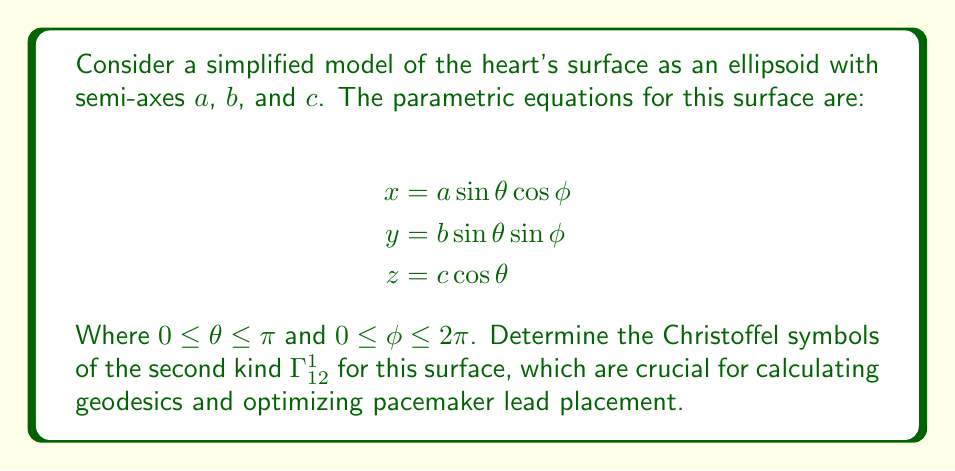Show me your answer to this math problem. To find the Christoffel symbol $\Gamma_{12}^1$, we need to follow these steps:

1) First, calculate the metric tensor components. The metric tensor is given by:

   $$g_{ij} = \frac{\partial \mathbf{r}}{\partial u_i} \cdot \frac{\partial \mathbf{r}}{\partial u_j}$$

   Where $\mathbf{r} = (x, y, z)$ and $(u_1, u_2) = (\theta, \phi)$.

2) Calculate the partial derivatives:

   $$\frac{\partial \mathbf{r}}{\partial \theta} = (a\cos\theta\cos\phi, b\cos\theta\sin\phi, -c\sin\theta)$$
   $$\frac{\partial \mathbf{r}}{\partial \phi} = (-a\sin\theta\sin\phi, b\sin\theta\cos\phi, 0)$$

3) Now, compute the metric tensor components:

   $$g_{11} = a^2\cos^2\theta\cos^2\phi + b^2\cos^2\theta\sin^2\phi + c^2\sin^2\theta$$
   $$g_{12} = g_{21} = -a^2\sin\theta\cos\theta\sin\phi\cos\phi + b^2\sin\theta\cos\theta\sin\phi\cos\phi = (b^2-a^2)\sin\theta\cos\theta\sin\phi\cos\phi$$
   $$g_{22} = a^2\sin^2\theta\sin^2\phi + b^2\sin^2\theta\cos^2\phi$$

4) The Christoffel symbol of the second kind is given by:

   $$\Gamma_{ij}^k = \frac{1}{2}g^{kl}\left(\frac{\partial g_{il}}{\partial u_j} + \frac{\partial g_{jl}}{\partial u_i} - \frac{\partial g_{ij}}{\partial u_l}\right)$$

   Where $g^{kl}$ are the components of the inverse metric tensor.

5) For $\Gamma_{12}^1$, we need to calculate:

   $$\Gamma_{12}^1 = \frac{1}{2}g^{11}\left(\frac{\partial g_{11}}{\partial \phi} + \frac{\partial g_{21}}{\partial \theta} - \frac{\partial g_{12}}{\partial \theta}\right)$$

6) Calculate the required partial derivatives:

   $$\frac{\partial g_{11}}{\partial \phi} = (a^2-b^2)\cos^2\theta\sin(2\phi)$$
   $$\frac{\partial g_{21}}{\partial \theta} = (b^2-a^2)(\cos^2\theta-\sin^2\theta)\sin\phi\cos\phi$$
   $$\frac{\partial g_{12}}{\partial \theta} = (b^2-a^2)(\cos^2\theta-\sin^2\theta)\sin\phi\cos\phi$$

7) Substitute these into the formula for $\Gamma_{12}^1$:

   $$\Gamma_{12}^1 = \frac{1}{2}g^{11}(a^2-b^2)\cos^2\theta\sin(2\phi)$$

This is the final expression for the Christoffel symbol $\Gamma_{12}^1$.
Answer: $$\Gamma_{12}^1 = \frac{1}{2}g^{11}(a^2-b^2)\cos^2\theta\sin(2\phi)$$ 